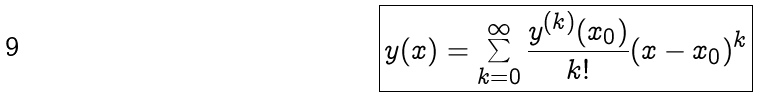Convert formula to latex. <formula><loc_0><loc_0><loc_500><loc_500>\boxed { y ( x ) = \sum _ { k = 0 } ^ { \infty } \frac { y ^ { ( k ) } ( x _ { 0 } ) } { k ! } ( x - x _ { 0 } ) ^ { k } }</formula> 